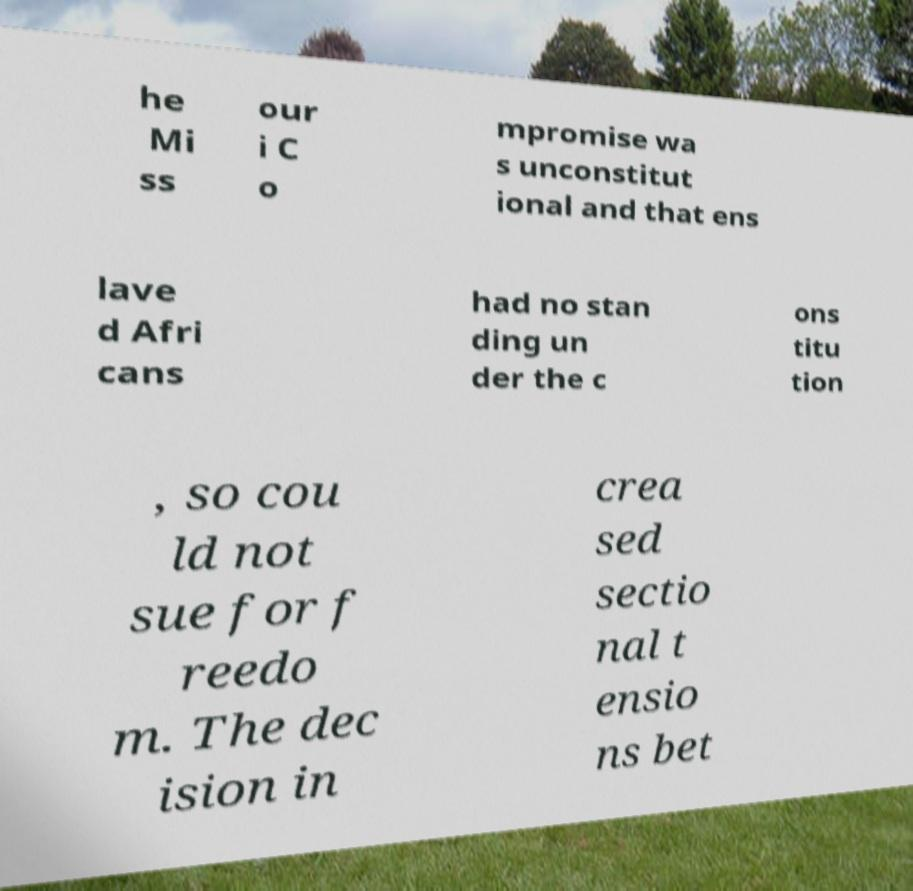Can you read and provide the text displayed in the image?This photo seems to have some interesting text. Can you extract and type it out for me? he Mi ss our i C o mpromise wa s unconstitut ional and that ens lave d Afri cans had no stan ding un der the c ons titu tion , so cou ld not sue for f reedo m. The dec ision in crea sed sectio nal t ensio ns bet 